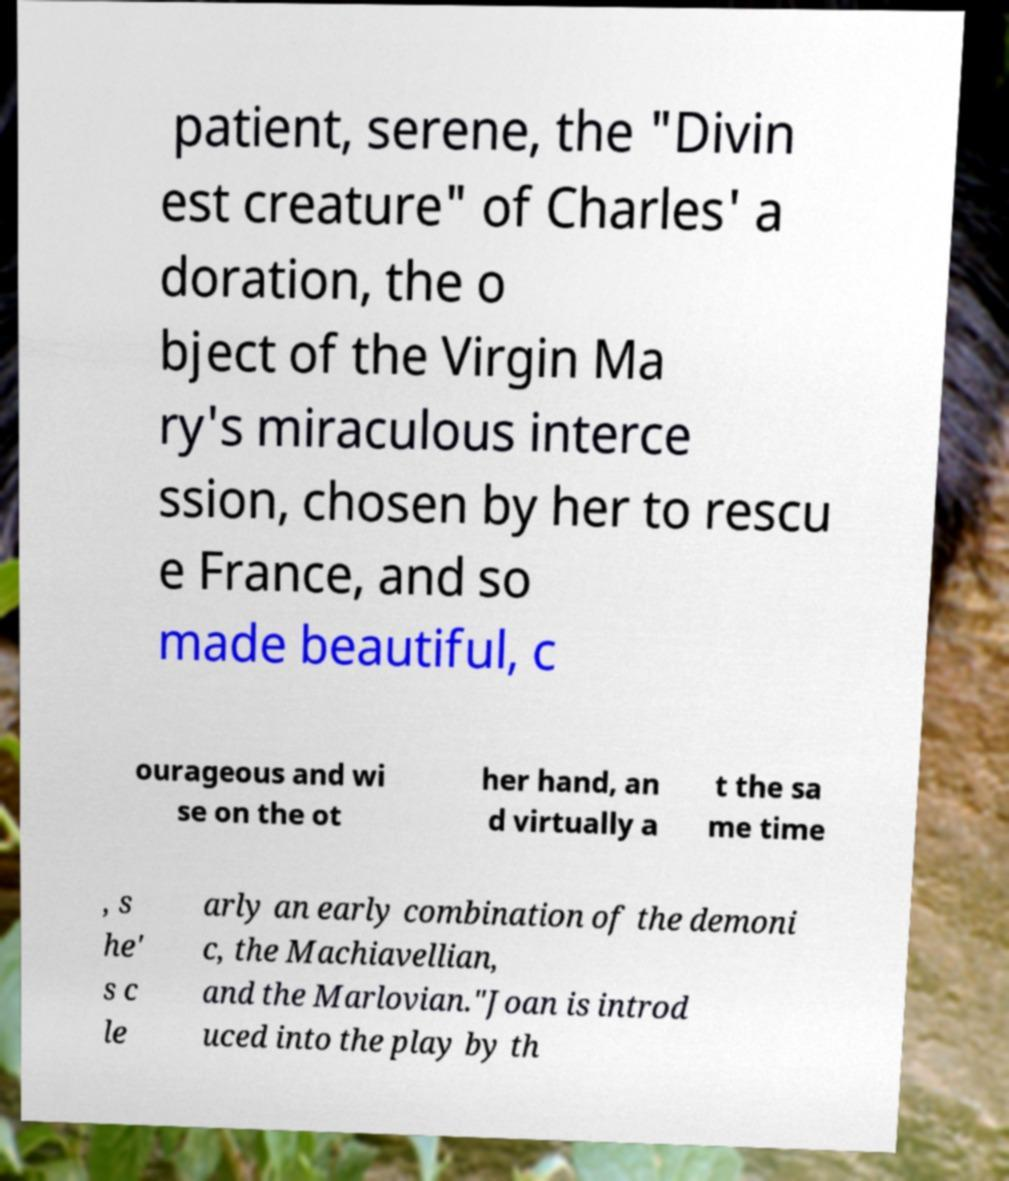Can you accurately transcribe the text from the provided image for me? patient, serene, the "Divin est creature" of Charles' a doration, the o bject of the Virgin Ma ry's miraculous interce ssion, chosen by her to rescu e France, and so made beautiful, c ourageous and wi se on the ot her hand, an d virtually a t the sa me time , s he' s c le arly an early combination of the demoni c, the Machiavellian, and the Marlovian."Joan is introd uced into the play by th 